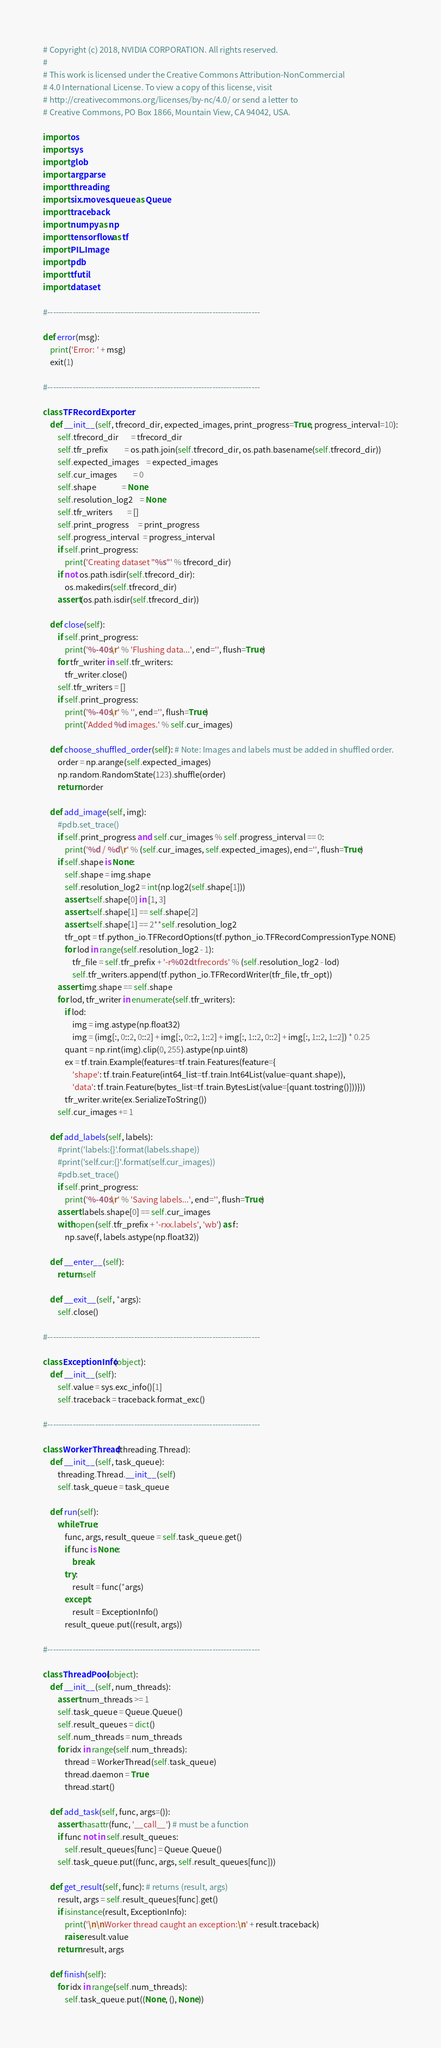<code> <loc_0><loc_0><loc_500><loc_500><_Python_># Copyright (c) 2018, NVIDIA CORPORATION. All rights reserved.
#
# This work is licensed under the Creative Commons Attribution-NonCommercial
# 4.0 International License. To view a copy of this license, visit
# http://creativecommons.org/licenses/by-nc/4.0/ or send a letter to
# Creative Commons, PO Box 1866, Mountain View, CA 94042, USA.

import os
import sys
import glob
import argparse
import threading
import six.moves.queue as Queue
import traceback
import numpy as np
import tensorflow as tf
import PIL.Image
import pdb
import tfutil
import dataset

#----------------------------------------------------------------------------

def error(msg):
    print('Error: ' + msg)
    exit(1)

#----------------------------------------------------------------------------

class TFRecordExporter:
    def __init__(self, tfrecord_dir, expected_images, print_progress=True, progress_interval=10):
        self.tfrecord_dir       = tfrecord_dir
        self.tfr_prefix         = os.path.join(self.tfrecord_dir, os.path.basename(self.tfrecord_dir))
        self.expected_images    = expected_images
        self.cur_images         = 0
        self.shape              = None
        self.resolution_log2    = None
        self.tfr_writers        = []
        self.print_progress     = print_progress
        self.progress_interval  = progress_interval
        if self.print_progress:
            print('Creating dataset "%s"' % tfrecord_dir)
        if not os.path.isdir(self.tfrecord_dir):
            os.makedirs(self.tfrecord_dir)
        assert(os.path.isdir(self.tfrecord_dir))
        
    def close(self):
        if self.print_progress:
            print('%-40s\r' % 'Flushing data...', end='', flush=True)
        for tfr_writer in self.tfr_writers:
            tfr_writer.close()
        self.tfr_writers = []
        if self.print_progress:
            print('%-40s\r' % '', end='', flush=True)
            print('Added %d images.' % self.cur_images)

    def choose_shuffled_order(self): # Note: Images and labels must be added in shuffled order.
        order = np.arange(self.expected_images)
        np.random.RandomState(123).shuffle(order)
        return order

    def add_image(self, img):
        #pdb.set_trace()
        if self.print_progress and self.cur_images % self.progress_interval == 0:
            print('%d / %d\r' % (self.cur_images, self.expected_images), end='', flush=True)
        if self.shape is None:
            self.shape = img.shape
            self.resolution_log2 = int(np.log2(self.shape[1]))
            assert self.shape[0] in [1, 3]
            assert self.shape[1] == self.shape[2]
            assert self.shape[1] == 2**self.resolution_log2
            tfr_opt = tf.python_io.TFRecordOptions(tf.python_io.TFRecordCompressionType.NONE)
            for lod in range(self.resolution_log2 - 1):
                tfr_file = self.tfr_prefix + '-r%02d.tfrecords' % (self.resolution_log2 - lod)
                self.tfr_writers.append(tf.python_io.TFRecordWriter(tfr_file, tfr_opt))
        assert img.shape == self.shape
        for lod, tfr_writer in enumerate(self.tfr_writers):
            if lod:
                img = img.astype(np.float32)
                img = (img[:, 0::2, 0::2] + img[:, 0::2, 1::2] + img[:, 1::2, 0::2] + img[:, 1::2, 1::2]) * 0.25
            quant = np.rint(img).clip(0, 255).astype(np.uint8)
            ex = tf.train.Example(features=tf.train.Features(feature={
                'shape': tf.train.Feature(int64_list=tf.train.Int64List(value=quant.shape)),
                'data': tf.train.Feature(bytes_list=tf.train.BytesList(value=[quant.tostring()]))}))
            tfr_writer.write(ex.SerializeToString())
        self.cur_images += 1

    def add_labels(self, labels):
        #print('labels:{}'.format(labels.shape))
        #print('self.cur:{}'.format(self.cur_images))
        #pdb.set_trace()
        if self.print_progress:
            print('%-40s\r' % 'Saving labels...', end='', flush=True)
        assert labels.shape[0] == self.cur_images
        with open(self.tfr_prefix + '-rxx.labels', 'wb') as f:
            np.save(f, labels.astype(np.float32))
            
    def __enter__(self):
        return self
    
    def __exit__(self, *args):
        self.close()

#----------------------------------------------------------------------------

class ExceptionInfo(object):
    def __init__(self):
        self.value = sys.exc_info()[1]
        self.traceback = traceback.format_exc()

#----------------------------------------------------------------------------

class WorkerThread(threading.Thread):
    def __init__(self, task_queue):
        threading.Thread.__init__(self)
        self.task_queue = task_queue

    def run(self):
        while True:
            func, args, result_queue = self.task_queue.get()
            if func is None:
                break
            try:
                result = func(*args)
            except:
                result = ExceptionInfo()
            result_queue.put((result, args))

#----------------------------------------------------------------------------

class ThreadPool(object):
    def __init__(self, num_threads):
        assert num_threads >= 1
        self.task_queue = Queue.Queue()
        self.result_queues = dict()
        self.num_threads = num_threads
        for idx in range(self.num_threads):
            thread = WorkerThread(self.task_queue)
            thread.daemon = True
            thread.start()

    def add_task(self, func, args=()):
        assert hasattr(func, '__call__') # must be a function
        if func not in self.result_queues:
            self.result_queues[func] = Queue.Queue()
        self.task_queue.put((func, args, self.result_queues[func]))

    def get_result(self, func): # returns (result, args)
        result, args = self.result_queues[func].get()
        if isinstance(result, ExceptionInfo):
            print('\n\nWorker thread caught an exception:\n' + result.traceback)
            raise result.value
        return result, args

    def finish(self):
        for idx in range(self.num_threads):
            self.task_queue.put((None, (), None))
</code> 